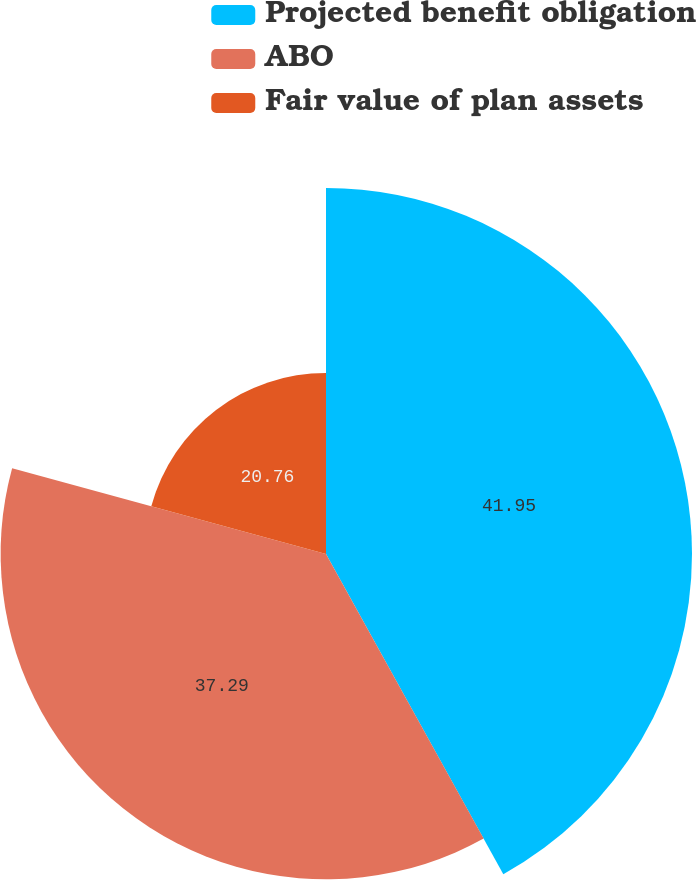Convert chart to OTSL. <chart><loc_0><loc_0><loc_500><loc_500><pie_chart><fcel>Projected benefit obligation<fcel>ABO<fcel>Fair value of plan assets<nl><fcel>41.95%<fcel>37.29%<fcel>20.76%<nl></chart> 